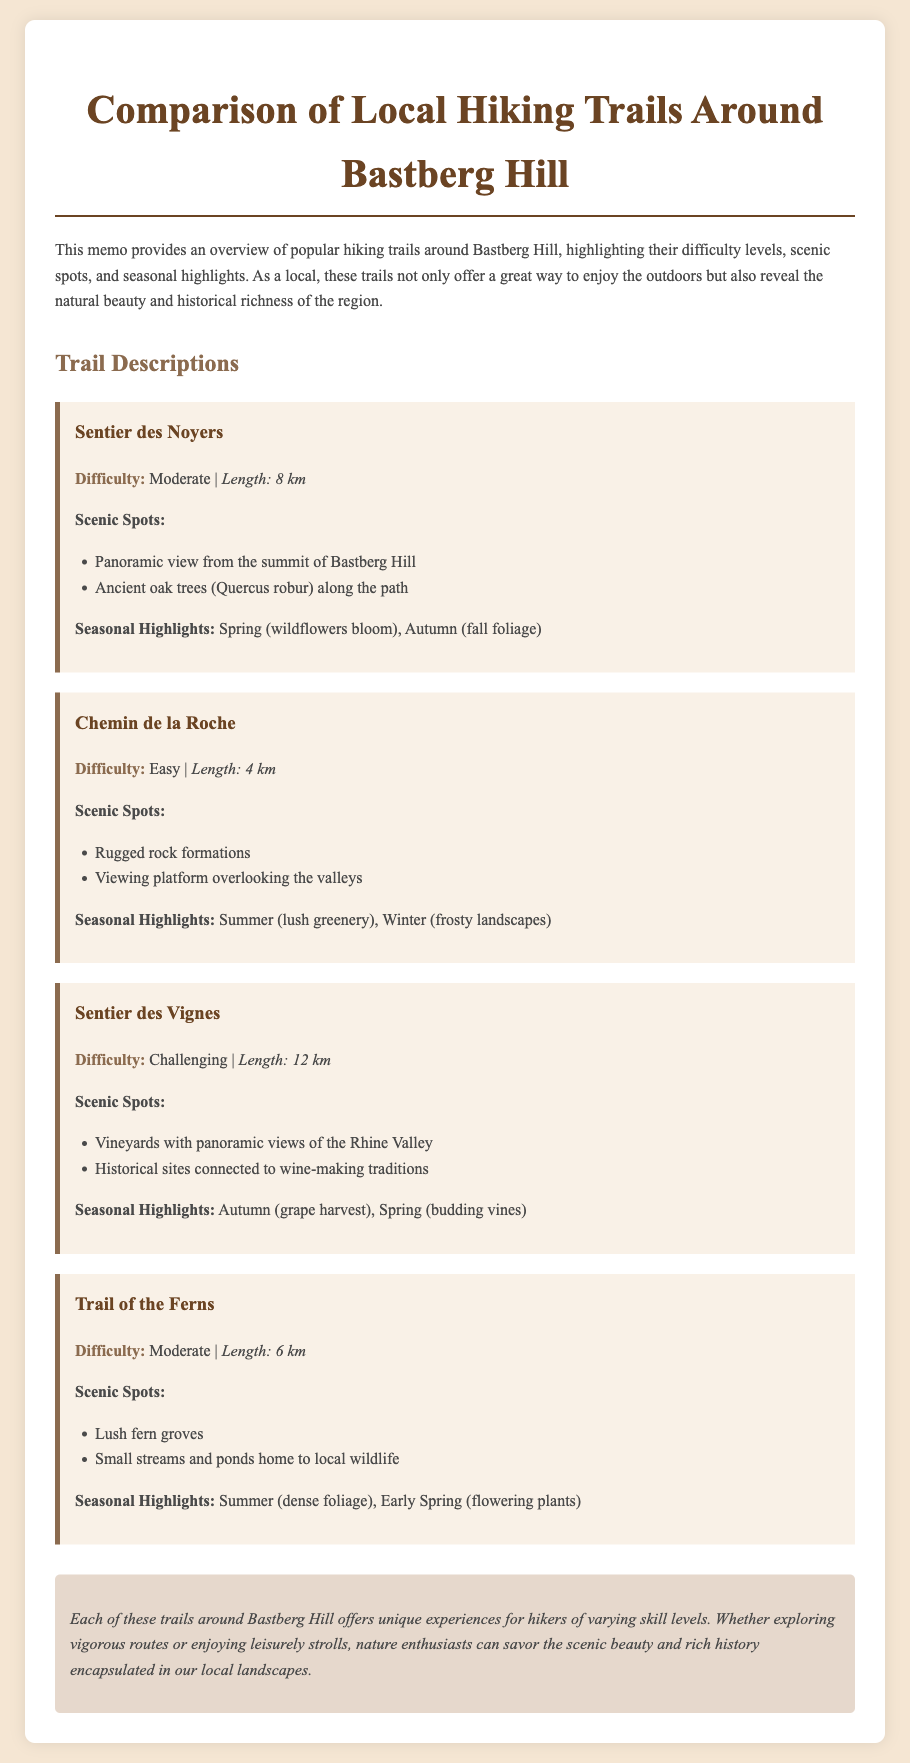What is the difficulty level of Sentier des Noyers? The difficulty level of Sentier des Noyers is explicitly mentioned in the document as "Moderate".
Answer: Moderate How long is the Chemin de la Roche? The length of the Chemin de la Roche is provided in the document as "4 km".
Answer: 4 km What seasonal highlight is associated with the Sentier des Vignes? The seasonal highlight of the Sentier des Vignes in Autumn is noted as "grape harvest".
Answer: grape harvest What scenic spot can be found along the Trail of the Ferns? The Trail of the Ferns features "Lush fern groves" as one of its scenic spots mentioned in the document.
Answer: Lush fern groves What type of memories might locals have of Bastberg Hill? The document emphasizes that the trails around Bastberg Hill reveal the "natural beauty and historical richness" of the region, suggesting a deep connection in local memories.
Answer: natural beauty and historical richness Which trail has the longest length? The document reveals that the "Sentier des Vignes" has a length of "12 km", making it the longest compared to other trails mentioned.
Answer: 12 km In which season would you expect to see wildflowers along the Sentier des Noyers? It is stated in the document that wildflowers bloom in "Spring" along the Sentier des Noyers.
Answer: Spring How many scenic spots are listed for Chemin de la Roche? The document lists "2" scenic spots for Chemin de la Roche, which helps to identify this trail's key features.
Answer: 2 